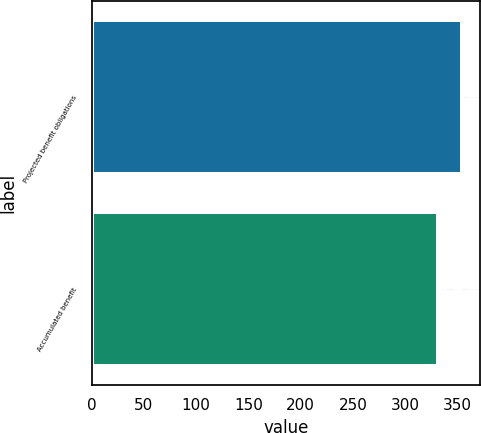Convert chart. <chart><loc_0><loc_0><loc_500><loc_500><bar_chart><fcel>Projected benefit obligations<fcel>Accumulated benefit<nl><fcel>354<fcel>331<nl></chart> 